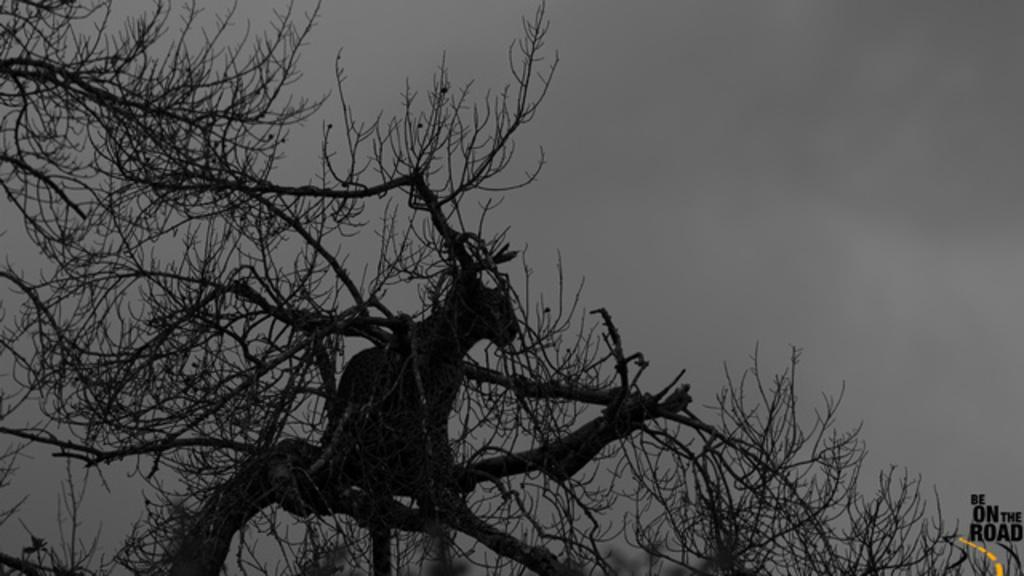In one or two sentences, can you explain what this image depicts? In this image we can see the branches of a tree. In the background, we can see the sky. 